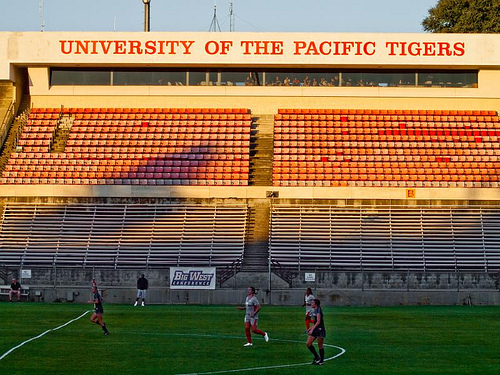<image>
Can you confirm if the person is on the field? Yes. Looking at the image, I can see the person is positioned on top of the field, with the field providing support. Where is the girl in relation to the sky? Is it to the right of the sky? No. The girl is not to the right of the sky. The horizontal positioning shows a different relationship. 